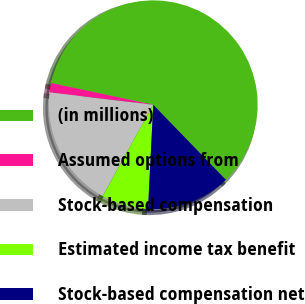<chart> <loc_0><loc_0><loc_500><loc_500><pie_chart><fcel>(in millions)<fcel>Assumed options from<fcel>Stock-based compensation<fcel>Estimated income tax benefit<fcel>Stock-based compensation net<nl><fcel>59.42%<fcel>1.45%<fcel>18.84%<fcel>7.25%<fcel>13.04%<nl></chart> 